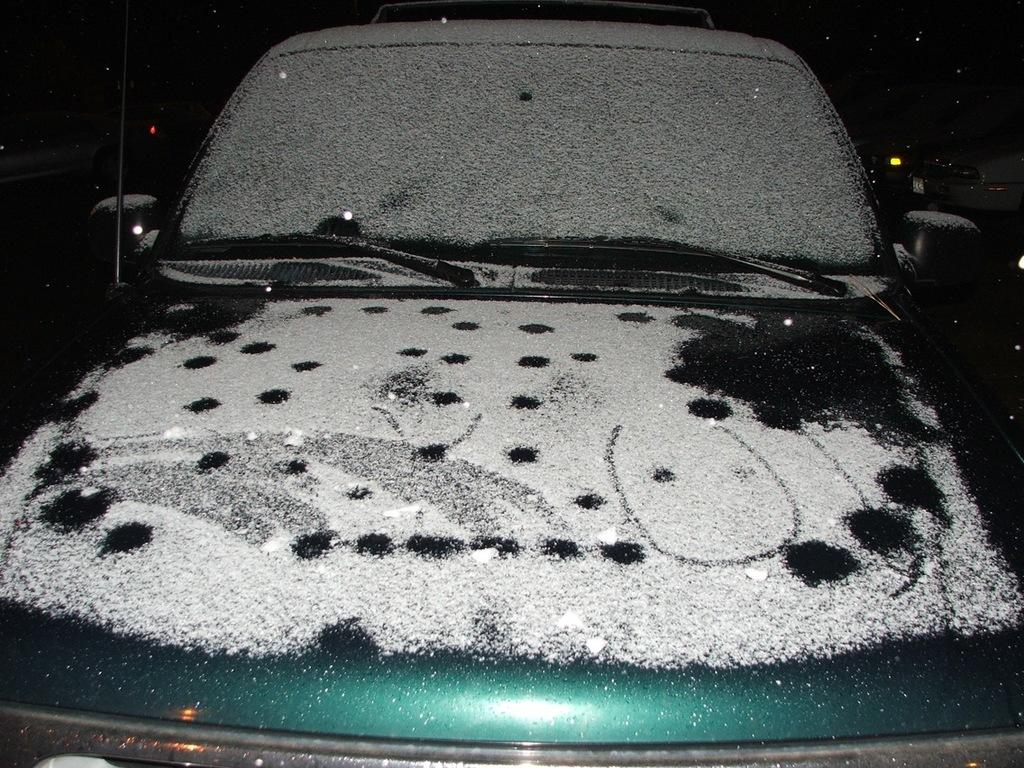What is the main subject of the image? There is a car in the image. Can you describe the condition of the car? There is snow on the car. How many servants are attending to the yak in the garden in the image? There is no yak or garden present in the image, and therefore no servants attending to them. 